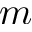<formula> <loc_0><loc_0><loc_500><loc_500>m</formula> 